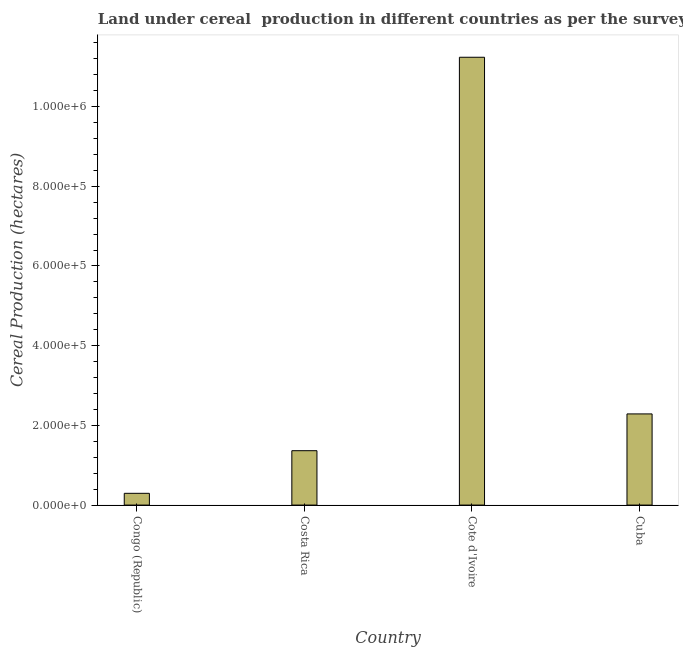Does the graph contain any zero values?
Give a very brief answer. No. What is the title of the graph?
Your answer should be compact. Land under cereal  production in different countries as per the survey of 1978. What is the label or title of the Y-axis?
Your answer should be very brief. Cereal Production (hectares). What is the land under cereal production in Cote d'Ivoire?
Keep it short and to the point. 1.12e+06. Across all countries, what is the maximum land under cereal production?
Your answer should be very brief. 1.12e+06. Across all countries, what is the minimum land under cereal production?
Your response must be concise. 2.95e+04. In which country was the land under cereal production maximum?
Give a very brief answer. Cote d'Ivoire. In which country was the land under cereal production minimum?
Your answer should be compact. Congo (Republic). What is the sum of the land under cereal production?
Ensure brevity in your answer.  1.52e+06. What is the difference between the land under cereal production in Costa Rica and Cuba?
Give a very brief answer. -9.23e+04. What is the average land under cereal production per country?
Offer a very short reply. 3.80e+05. What is the median land under cereal production?
Provide a short and direct response. 1.83e+05. In how many countries, is the land under cereal production greater than 120000 hectares?
Provide a short and direct response. 3. What is the ratio of the land under cereal production in Costa Rica to that in Cuba?
Give a very brief answer. 0.6. Is the land under cereal production in Costa Rica less than that in Cuba?
Your answer should be very brief. Yes. Is the difference between the land under cereal production in Congo (Republic) and Cuba greater than the difference between any two countries?
Give a very brief answer. No. What is the difference between the highest and the second highest land under cereal production?
Your answer should be compact. 8.95e+05. What is the difference between the highest and the lowest land under cereal production?
Ensure brevity in your answer.  1.09e+06. How many bars are there?
Give a very brief answer. 4. How many countries are there in the graph?
Your answer should be compact. 4. What is the Cereal Production (hectares) of Congo (Republic)?
Your response must be concise. 2.95e+04. What is the Cereal Production (hectares) of Costa Rica?
Keep it short and to the point. 1.36e+05. What is the Cereal Production (hectares) in Cote d'Ivoire?
Offer a terse response. 1.12e+06. What is the Cereal Production (hectares) in Cuba?
Ensure brevity in your answer.  2.29e+05. What is the difference between the Cereal Production (hectares) in Congo (Republic) and Costa Rica?
Keep it short and to the point. -1.07e+05. What is the difference between the Cereal Production (hectares) in Congo (Republic) and Cote d'Ivoire?
Keep it short and to the point. -1.09e+06. What is the difference between the Cereal Production (hectares) in Congo (Republic) and Cuba?
Keep it short and to the point. -1.99e+05. What is the difference between the Cereal Production (hectares) in Costa Rica and Cote d'Ivoire?
Keep it short and to the point. -9.87e+05. What is the difference between the Cereal Production (hectares) in Costa Rica and Cuba?
Your response must be concise. -9.23e+04. What is the difference between the Cereal Production (hectares) in Cote d'Ivoire and Cuba?
Your answer should be compact. 8.95e+05. What is the ratio of the Cereal Production (hectares) in Congo (Republic) to that in Costa Rica?
Provide a succinct answer. 0.22. What is the ratio of the Cereal Production (hectares) in Congo (Republic) to that in Cote d'Ivoire?
Offer a terse response. 0.03. What is the ratio of the Cereal Production (hectares) in Congo (Republic) to that in Cuba?
Offer a terse response. 0.13. What is the ratio of the Cereal Production (hectares) in Costa Rica to that in Cote d'Ivoire?
Give a very brief answer. 0.12. What is the ratio of the Cereal Production (hectares) in Costa Rica to that in Cuba?
Ensure brevity in your answer.  0.6. What is the ratio of the Cereal Production (hectares) in Cote d'Ivoire to that in Cuba?
Keep it short and to the point. 4.91. 